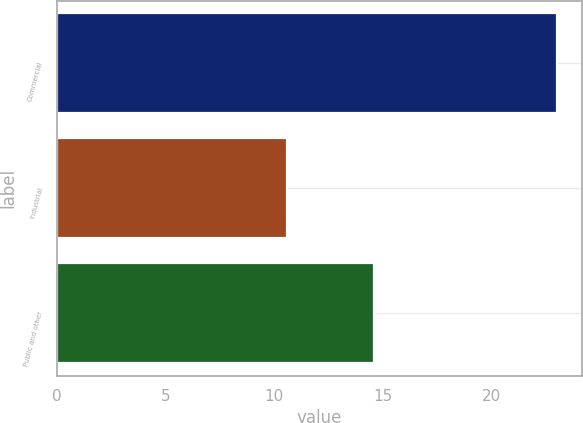Convert chart. <chart><loc_0><loc_0><loc_500><loc_500><bar_chart><fcel>Commercial<fcel>Industrial<fcel>Public and other<nl><fcel>23<fcel>10.6<fcel>14.6<nl></chart> 